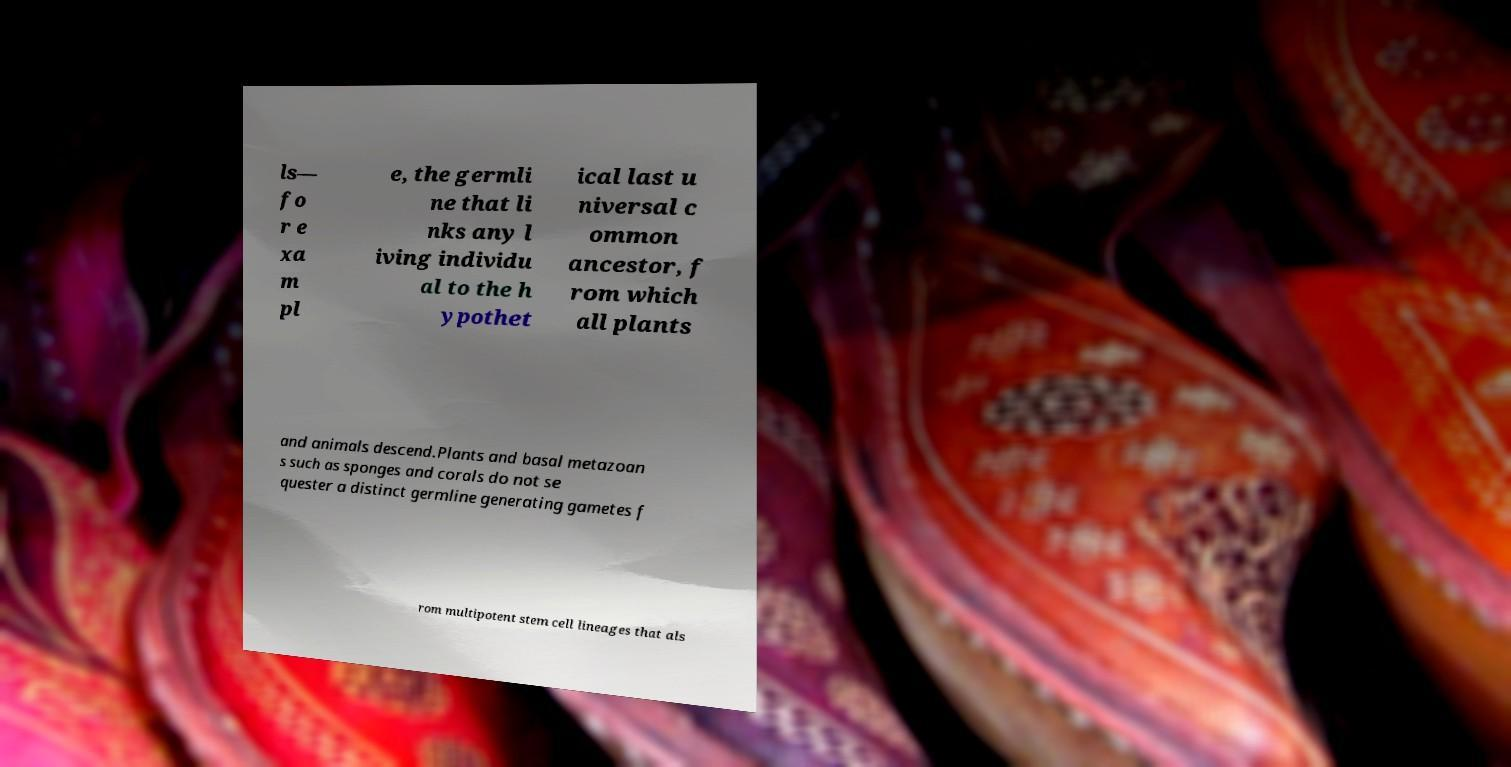For documentation purposes, I need the text within this image transcribed. Could you provide that? ls— fo r e xa m pl e, the germli ne that li nks any l iving individu al to the h ypothet ical last u niversal c ommon ancestor, f rom which all plants and animals descend.Plants and basal metazoan s such as sponges and corals do not se quester a distinct germline generating gametes f rom multipotent stem cell lineages that als 